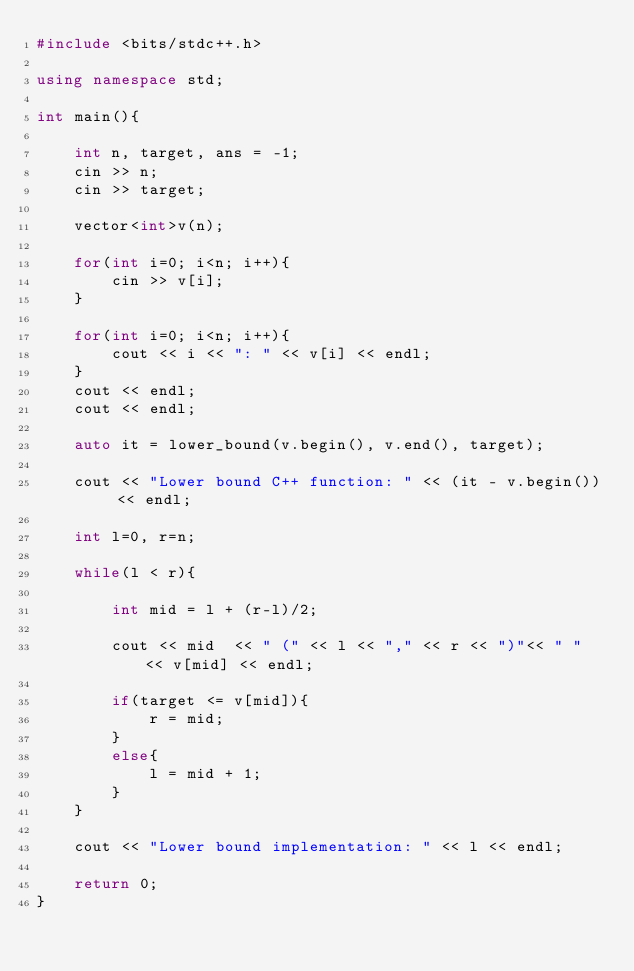<code> <loc_0><loc_0><loc_500><loc_500><_C++_>#include <bits/stdc++.h>

using namespace std;

int main(){

    int n, target, ans = -1;
    cin >> n;
    cin >> target;

    vector<int>v(n);

    for(int i=0; i<n; i++){
        cin >> v[i];
    }

    for(int i=0; i<n; i++){
        cout << i << ": " << v[i] << endl;
    }
    cout << endl;
    cout << endl;

    auto it = lower_bound(v.begin(), v.end(), target);

    cout << "Lower bound C++ function: " << (it - v.begin()) << endl;

    int l=0, r=n;

    while(l < r){

        int mid = l + (r-l)/2;

        cout << mid  << " (" << l << "," << r << ")"<< " " << v[mid] << endl;

        if(target <= v[mid]){
            r = mid;
        }
        else{
            l = mid + 1;
        }
    }

    cout << "Lower bound implementation: " << l << endl;

    return 0;
}</code> 